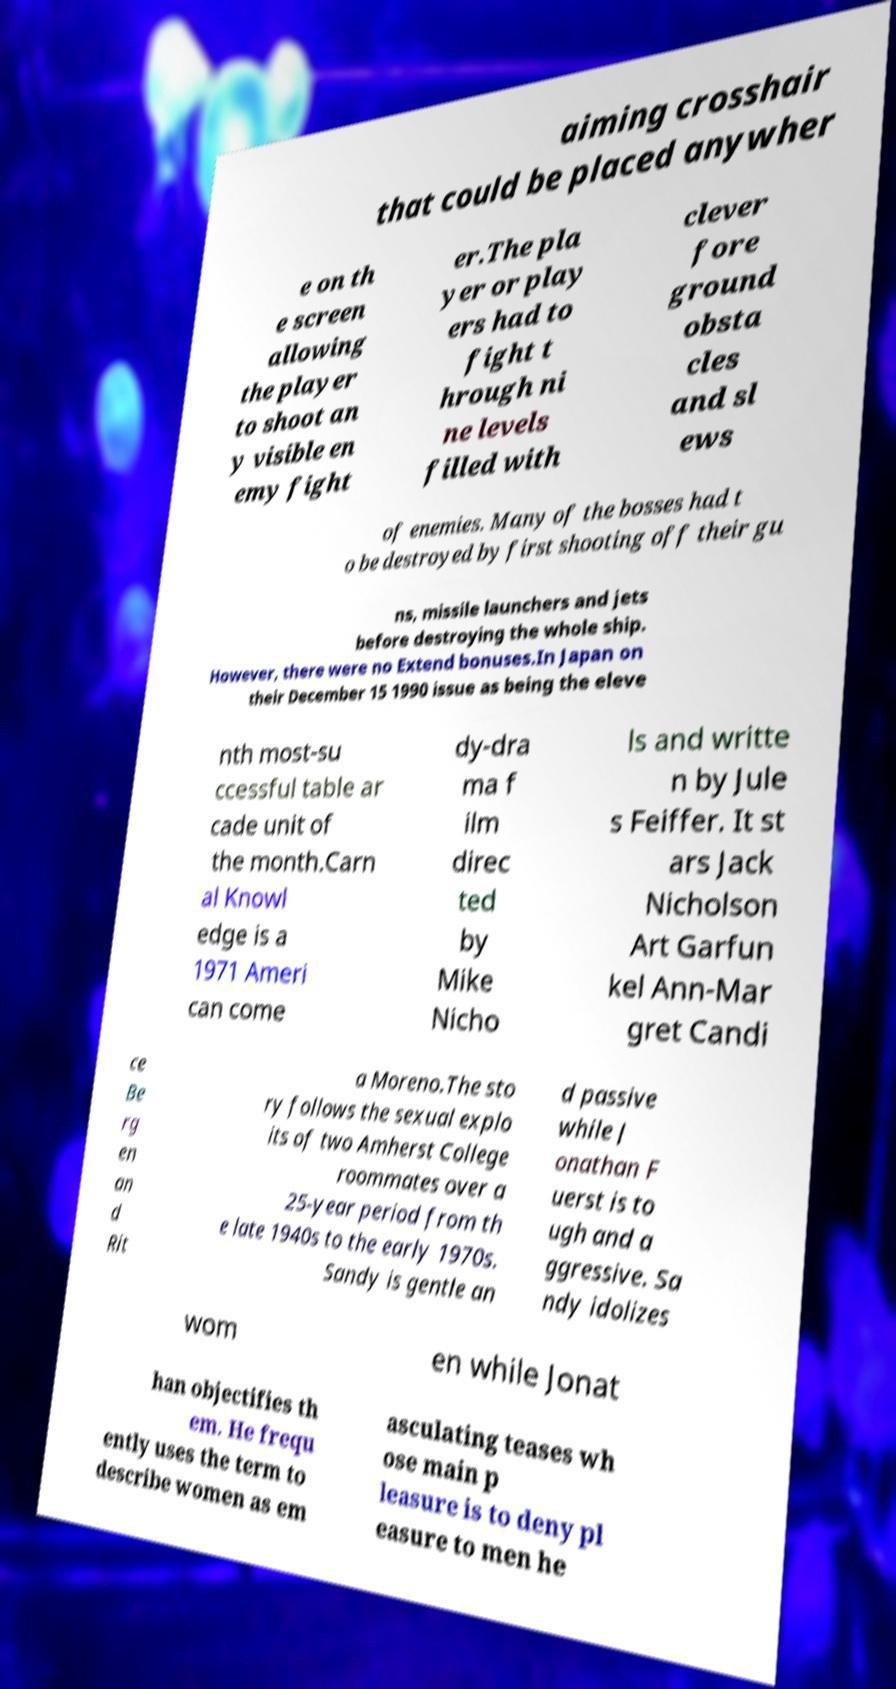For documentation purposes, I need the text within this image transcribed. Could you provide that? aiming crosshair that could be placed anywher e on th e screen allowing the player to shoot an y visible en emy fight er.The pla yer or play ers had to fight t hrough ni ne levels filled with clever fore ground obsta cles and sl ews of enemies. Many of the bosses had t o be destroyed by first shooting off their gu ns, missile launchers and jets before destroying the whole ship. However, there were no Extend bonuses.In Japan on their December 15 1990 issue as being the eleve nth most-su ccessful table ar cade unit of the month.Carn al Knowl edge is a 1971 Ameri can come dy-dra ma f ilm direc ted by Mike Nicho ls and writte n by Jule s Feiffer. It st ars Jack Nicholson Art Garfun kel Ann-Mar gret Candi ce Be rg en an d Rit a Moreno.The sto ry follows the sexual explo its of two Amherst College roommates over a 25-year period from th e late 1940s to the early 1970s. Sandy is gentle an d passive while J onathan F uerst is to ugh and a ggressive. Sa ndy idolizes wom en while Jonat han objectifies th em. He frequ ently uses the term to describe women as em asculating teases wh ose main p leasure is to deny pl easure to men he 